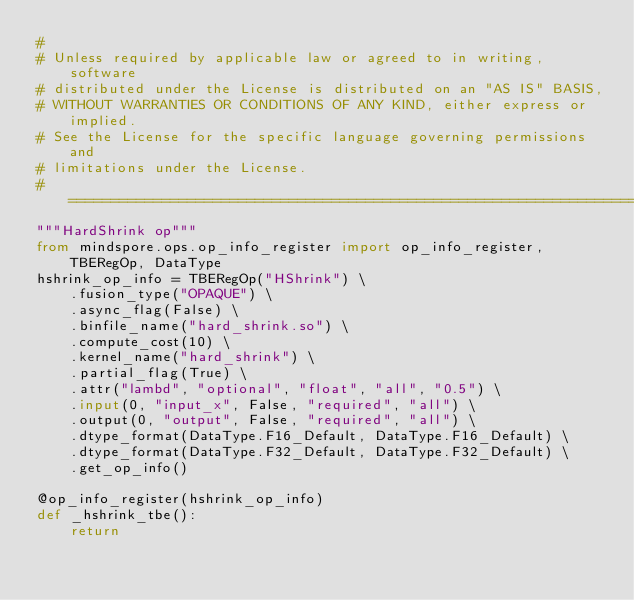Convert code to text. <code><loc_0><loc_0><loc_500><loc_500><_Python_>#
# Unless required by applicable law or agreed to in writing, software
# distributed under the License is distributed on an "AS IS" BASIS,
# WITHOUT WARRANTIES OR CONDITIONS OF ANY KIND, either express or implied.
# See the License for the specific language governing permissions and
# limitations under the License.
# ============================================================================
"""HardShrink op"""
from mindspore.ops.op_info_register import op_info_register, TBERegOp, DataType
hshrink_op_info = TBERegOp("HShrink") \
    .fusion_type("OPAQUE") \
    .async_flag(False) \
    .binfile_name("hard_shrink.so") \
    .compute_cost(10) \
    .kernel_name("hard_shrink") \
    .partial_flag(True) \
    .attr("lambd", "optional", "float", "all", "0.5") \
    .input(0, "input_x", False, "required", "all") \
    .output(0, "output", False, "required", "all") \
    .dtype_format(DataType.F16_Default, DataType.F16_Default) \
    .dtype_format(DataType.F32_Default, DataType.F32_Default) \
    .get_op_info()

@op_info_register(hshrink_op_info)
def _hshrink_tbe():
    return
</code> 